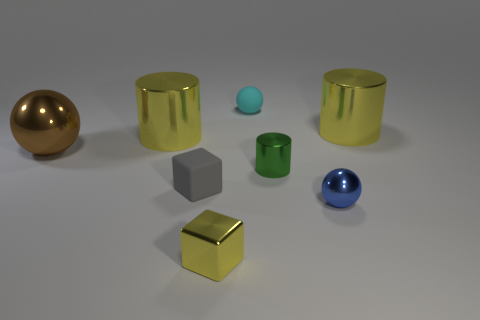Can you describe the different materials that the objects appear to be made of? Certainly! The objects in the image exhibit a variety of materials with distinct characteristics. The spherical objects, for example, have a reflective surface suggesting they could be metallic. In contrast, the cubes have a matte finish, which may imply a plastic or non-metallic composition. The cylindrical items similarly have reflective surfaces, hinting at metallic properties. 